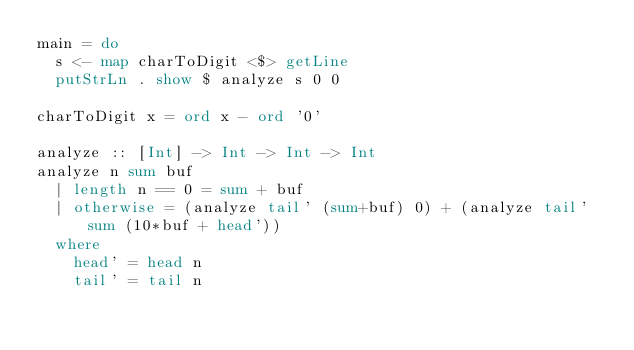<code> <loc_0><loc_0><loc_500><loc_500><_Haskell_>main = do
  s <- map charToDigit <$> getLine
  putStrLn . show $ analyze s 0 0

charToDigit x = ord x - ord '0'

analyze :: [Int] -> Int -> Int -> Int
analyze n sum buf
  | length n == 0 = sum + buf
  | otherwise = (analyze tail' (sum+buf) 0) + (analyze tail' sum (10*buf + head'))
  where
    head' = head n
    tail' = tail n
</code> 